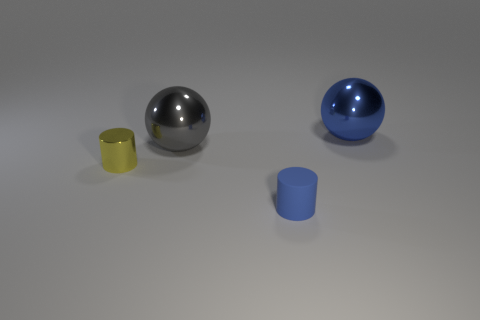Add 3 gray things. How many objects exist? 7 Subtract 0 blue blocks. How many objects are left? 4 Subtract all green things. Subtract all big gray things. How many objects are left? 3 Add 4 large things. How many large things are left? 6 Add 2 spheres. How many spheres exist? 4 